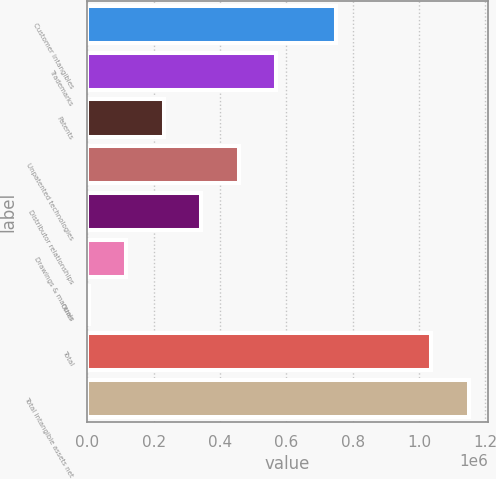Convert chart. <chart><loc_0><loc_0><loc_500><loc_500><bar_chart><fcel>Customer intangibles<fcel>Trademarks<fcel>Patents<fcel>Unpatented technologies<fcel>Distributor relationships<fcel>Drawings & manuals<fcel>Other<fcel>Total<fcel>Total intangible assets net<nl><fcel>750437<fcel>569734<fcel>231020<fcel>456829<fcel>343924<fcel>118116<fcel>5211<fcel>1.03759e+06<fcel>1.15049e+06<nl></chart> 